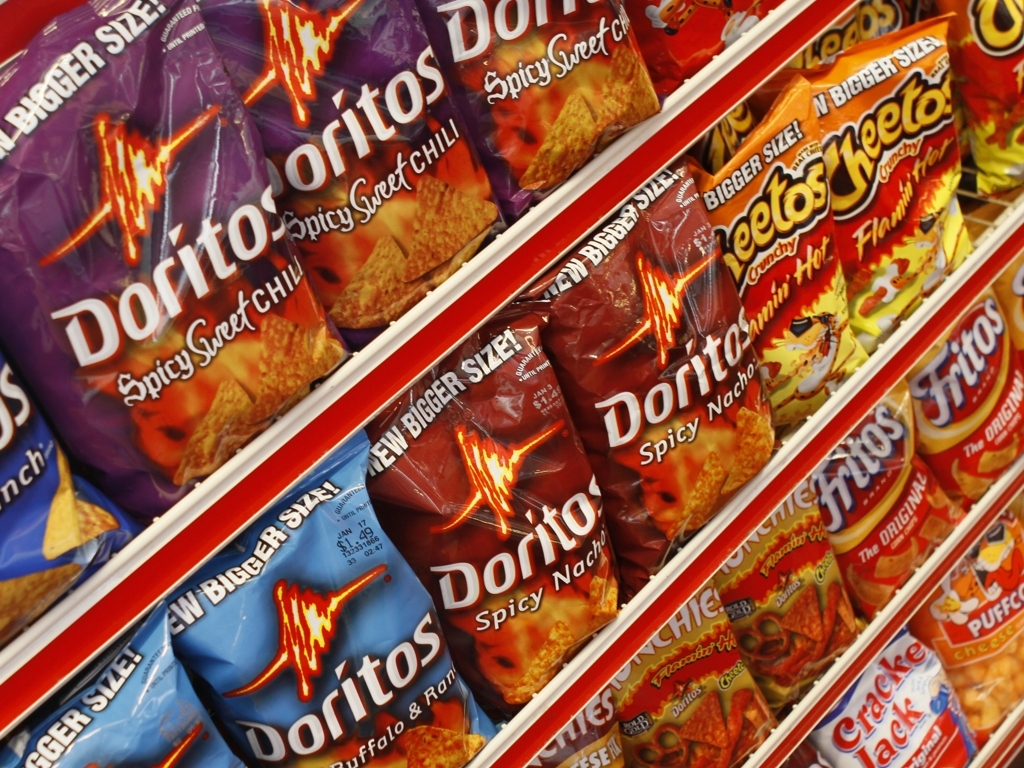Are the patterns and letters on the packaging clear? The patterns and letters on the packaging are prominently displayed and easily readable, with vibrant colors that stand out against the background. Each variety of Doritos has a unique color scheme and design that differentiates it from the others on the shelf. 